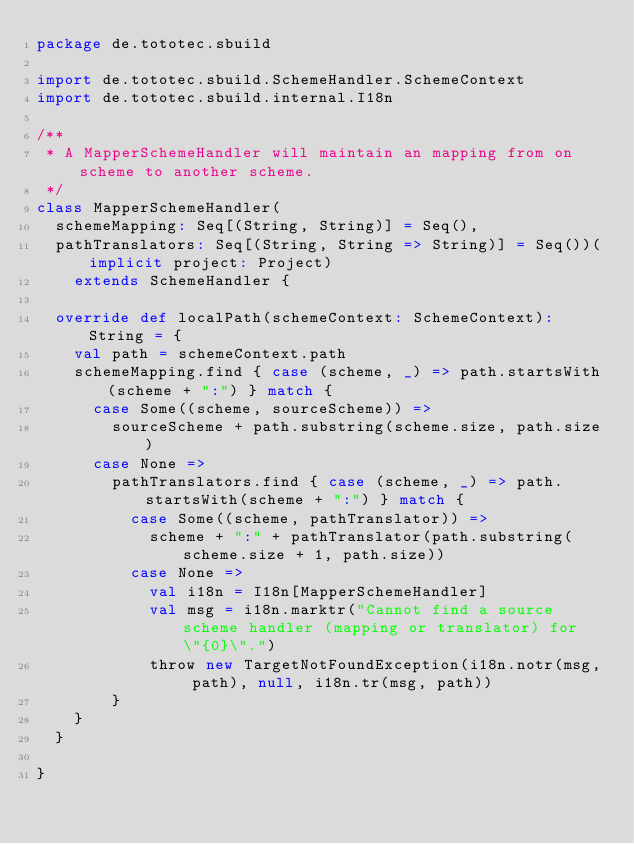Convert code to text. <code><loc_0><loc_0><loc_500><loc_500><_Scala_>package de.tototec.sbuild

import de.tototec.sbuild.SchemeHandler.SchemeContext
import de.tototec.sbuild.internal.I18n

/**
 * A MapperSchemeHandler will maintain an mapping from on scheme to another scheme.
 */
class MapperSchemeHandler(
  schemeMapping: Seq[(String, String)] = Seq(),
  pathTranslators: Seq[(String, String => String)] = Seq())(implicit project: Project)
    extends SchemeHandler {

  override def localPath(schemeContext: SchemeContext): String = {
    val path = schemeContext.path
    schemeMapping.find { case (scheme, _) => path.startsWith(scheme + ":") } match {
      case Some((scheme, sourceScheme)) =>
        sourceScheme + path.substring(scheme.size, path.size)
      case None =>
        pathTranslators.find { case (scheme, _) => path.startsWith(scheme + ":") } match {
          case Some((scheme, pathTranslator)) =>
            scheme + ":" + pathTranslator(path.substring(scheme.size + 1, path.size))
          case None =>
            val i18n = I18n[MapperSchemeHandler]
            val msg = i18n.marktr("Cannot find a source scheme handler (mapping or translator) for \"{0}\".")
            throw new TargetNotFoundException(i18n.notr(msg, path), null, i18n.tr(msg, path))
        }
    }
  }

}</code> 